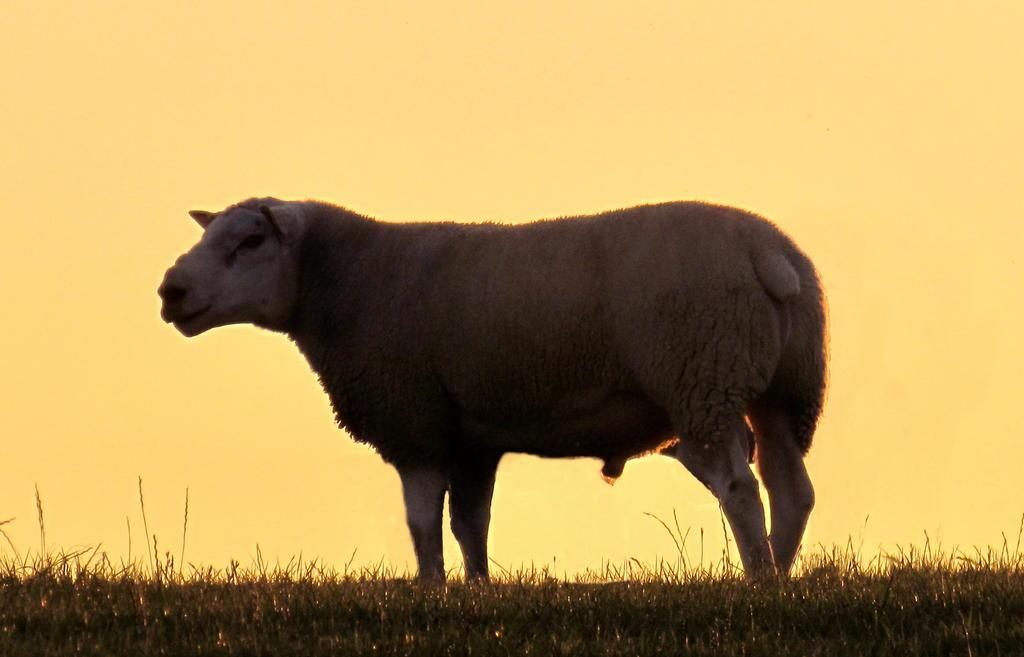What is the main subject in the center of the image? There is an animal in the center of the image. What is the animal doing in the image? The animal is standing. What type of vegetation can be seen on the ground in the image? There is grass on the ground in the front of the image. Where is the faucet located in the image? There is no faucet present in the image. What type of plants can be seen growing on the animal in the image? There are no plants growing on the animal in the image. 